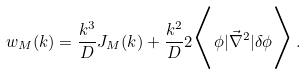Convert formula to latex. <formula><loc_0><loc_0><loc_500><loc_500>w _ { M } ( k ) = \frac { k ^ { 3 } } { D } J _ { M } ( k ) + \frac { k ^ { 2 } } { D } 2 \Big < \phi | { \vec { \nabla } } ^ { 2 } | \delta \phi \Big > \, .</formula> 